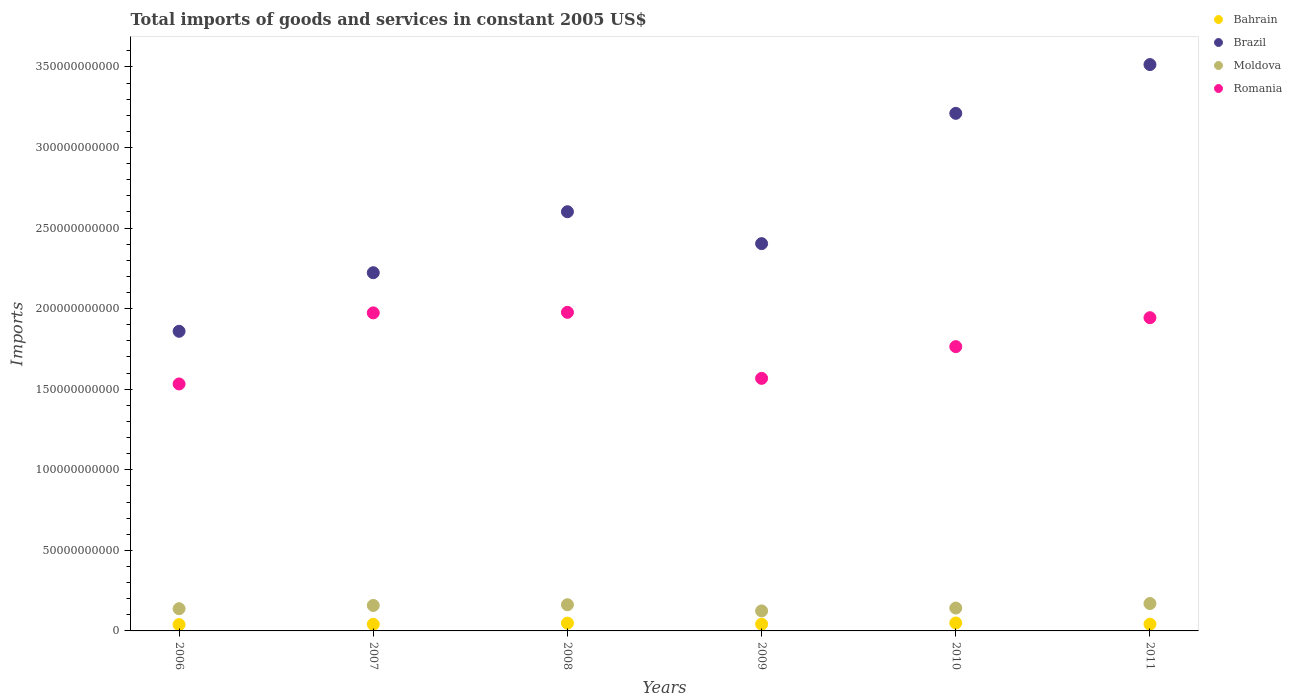Is the number of dotlines equal to the number of legend labels?
Your answer should be very brief. Yes. What is the total imports of goods and services in Bahrain in 2009?
Offer a very short reply. 4.20e+09. Across all years, what is the maximum total imports of goods and services in Bahrain?
Offer a very short reply. 4.92e+09. Across all years, what is the minimum total imports of goods and services in Bahrain?
Provide a short and direct response. 3.93e+09. What is the total total imports of goods and services in Romania in the graph?
Ensure brevity in your answer.  1.08e+12. What is the difference between the total imports of goods and services in Moldova in 2009 and that in 2010?
Provide a succinct answer. -1.77e+09. What is the difference between the total imports of goods and services in Bahrain in 2006 and the total imports of goods and services in Romania in 2010?
Give a very brief answer. -1.72e+11. What is the average total imports of goods and services in Brazil per year?
Your answer should be very brief. 2.64e+11. In the year 2009, what is the difference between the total imports of goods and services in Romania and total imports of goods and services in Moldova?
Ensure brevity in your answer.  1.44e+11. What is the ratio of the total imports of goods and services in Moldova in 2007 to that in 2011?
Your answer should be very brief. 0.93. Is the difference between the total imports of goods and services in Romania in 2006 and 2008 greater than the difference between the total imports of goods and services in Moldova in 2006 and 2008?
Provide a short and direct response. No. What is the difference between the highest and the second highest total imports of goods and services in Bahrain?
Your answer should be very brief. 9.00e+07. What is the difference between the highest and the lowest total imports of goods and services in Bahrain?
Ensure brevity in your answer.  9.95e+08. Is the sum of the total imports of goods and services in Moldova in 2008 and 2010 greater than the maximum total imports of goods and services in Brazil across all years?
Your response must be concise. No. Does the total imports of goods and services in Brazil monotonically increase over the years?
Your answer should be compact. No. Is the total imports of goods and services in Bahrain strictly less than the total imports of goods and services in Moldova over the years?
Give a very brief answer. Yes. How many dotlines are there?
Your answer should be compact. 4. How many years are there in the graph?
Provide a succinct answer. 6. Does the graph contain any zero values?
Your response must be concise. No. Does the graph contain grids?
Keep it short and to the point. No. Where does the legend appear in the graph?
Offer a very short reply. Top right. How many legend labels are there?
Your response must be concise. 4. What is the title of the graph?
Offer a terse response. Total imports of goods and services in constant 2005 US$. What is the label or title of the Y-axis?
Your answer should be compact. Imports. What is the Imports of Bahrain in 2006?
Make the answer very short. 3.93e+09. What is the Imports in Brazil in 2006?
Your answer should be compact. 1.86e+11. What is the Imports of Moldova in 2006?
Offer a very short reply. 1.38e+1. What is the Imports of Romania in 2006?
Offer a terse response. 1.53e+11. What is the Imports in Bahrain in 2007?
Keep it short and to the point. 4.10e+09. What is the Imports of Brazil in 2007?
Your answer should be compact. 2.22e+11. What is the Imports of Moldova in 2007?
Give a very brief answer. 1.58e+1. What is the Imports in Romania in 2007?
Offer a very short reply. 1.97e+11. What is the Imports of Bahrain in 2008?
Provide a short and direct response. 4.83e+09. What is the Imports in Brazil in 2008?
Your answer should be very brief. 2.60e+11. What is the Imports in Moldova in 2008?
Ensure brevity in your answer.  1.63e+1. What is the Imports of Romania in 2008?
Offer a terse response. 1.98e+11. What is the Imports of Bahrain in 2009?
Provide a short and direct response. 4.20e+09. What is the Imports of Brazil in 2009?
Offer a terse response. 2.40e+11. What is the Imports of Moldova in 2009?
Your response must be concise. 1.24e+1. What is the Imports in Romania in 2009?
Ensure brevity in your answer.  1.57e+11. What is the Imports of Bahrain in 2010?
Provide a succinct answer. 4.92e+09. What is the Imports in Brazil in 2010?
Provide a short and direct response. 3.21e+11. What is the Imports of Moldova in 2010?
Make the answer very short. 1.42e+1. What is the Imports in Romania in 2010?
Give a very brief answer. 1.76e+11. What is the Imports in Bahrain in 2011?
Your answer should be very brief. 4.20e+09. What is the Imports of Brazil in 2011?
Ensure brevity in your answer.  3.51e+11. What is the Imports in Moldova in 2011?
Offer a terse response. 1.70e+1. What is the Imports of Romania in 2011?
Offer a terse response. 1.94e+11. Across all years, what is the maximum Imports in Bahrain?
Offer a very short reply. 4.92e+09. Across all years, what is the maximum Imports in Brazil?
Keep it short and to the point. 3.51e+11. Across all years, what is the maximum Imports of Moldova?
Offer a very short reply. 1.70e+1. Across all years, what is the maximum Imports in Romania?
Provide a succinct answer. 1.98e+11. Across all years, what is the minimum Imports of Bahrain?
Make the answer very short. 3.93e+09. Across all years, what is the minimum Imports in Brazil?
Offer a terse response. 1.86e+11. Across all years, what is the minimum Imports in Moldova?
Offer a very short reply. 1.24e+1. Across all years, what is the minimum Imports of Romania?
Offer a terse response. 1.53e+11. What is the total Imports in Bahrain in the graph?
Offer a terse response. 2.62e+1. What is the total Imports in Brazil in the graph?
Provide a short and direct response. 1.58e+12. What is the total Imports in Moldova in the graph?
Make the answer very short. 8.94e+1. What is the total Imports of Romania in the graph?
Your answer should be compact. 1.08e+12. What is the difference between the Imports in Bahrain in 2006 and that in 2007?
Provide a succinct answer. -1.75e+08. What is the difference between the Imports of Brazil in 2006 and that in 2007?
Your answer should be compact. -3.64e+1. What is the difference between the Imports of Moldova in 2006 and that in 2007?
Ensure brevity in your answer.  -2.01e+09. What is the difference between the Imports of Romania in 2006 and that in 2007?
Ensure brevity in your answer.  -4.41e+1. What is the difference between the Imports in Bahrain in 2006 and that in 2008?
Offer a terse response. -9.05e+08. What is the difference between the Imports of Brazil in 2006 and that in 2008?
Offer a terse response. -7.42e+1. What is the difference between the Imports in Moldova in 2006 and that in 2008?
Keep it short and to the point. -2.46e+09. What is the difference between the Imports in Romania in 2006 and that in 2008?
Keep it short and to the point. -4.44e+1. What is the difference between the Imports in Bahrain in 2006 and that in 2009?
Provide a short and direct response. -2.68e+08. What is the difference between the Imports of Brazil in 2006 and that in 2009?
Make the answer very short. -5.44e+1. What is the difference between the Imports of Moldova in 2006 and that in 2009?
Ensure brevity in your answer.  1.37e+09. What is the difference between the Imports in Romania in 2006 and that in 2009?
Your response must be concise. -3.47e+09. What is the difference between the Imports in Bahrain in 2006 and that in 2010?
Keep it short and to the point. -9.95e+08. What is the difference between the Imports of Brazil in 2006 and that in 2010?
Provide a short and direct response. -1.35e+11. What is the difference between the Imports of Moldova in 2006 and that in 2010?
Offer a very short reply. -4.05e+08. What is the difference between the Imports of Romania in 2006 and that in 2010?
Your answer should be compact. -2.32e+1. What is the difference between the Imports of Bahrain in 2006 and that in 2011?
Provide a succinct answer. -2.68e+08. What is the difference between the Imports in Brazil in 2006 and that in 2011?
Offer a terse response. -1.66e+11. What is the difference between the Imports in Moldova in 2006 and that in 2011?
Your answer should be very brief. -3.20e+09. What is the difference between the Imports in Romania in 2006 and that in 2011?
Your answer should be very brief. -4.11e+1. What is the difference between the Imports in Bahrain in 2007 and that in 2008?
Give a very brief answer. -7.30e+08. What is the difference between the Imports of Brazil in 2007 and that in 2008?
Your answer should be very brief. -3.78e+1. What is the difference between the Imports in Moldova in 2007 and that in 2008?
Your answer should be very brief. -4.51e+08. What is the difference between the Imports in Romania in 2007 and that in 2008?
Make the answer very short. -3.45e+08. What is the difference between the Imports in Bahrain in 2007 and that in 2009?
Give a very brief answer. -9.39e+07. What is the difference between the Imports in Brazil in 2007 and that in 2009?
Ensure brevity in your answer.  -1.80e+1. What is the difference between the Imports of Moldova in 2007 and that in 2009?
Keep it short and to the point. 3.38e+09. What is the difference between the Imports in Romania in 2007 and that in 2009?
Give a very brief answer. 4.06e+1. What is the difference between the Imports of Bahrain in 2007 and that in 2010?
Offer a very short reply. -8.20e+08. What is the difference between the Imports in Brazil in 2007 and that in 2010?
Your answer should be compact. -9.89e+1. What is the difference between the Imports in Moldova in 2007 and that in 2010?
Provide a succinct answer. 1.61e+09. What is the difference between the Imports of Romania in 2007 and that in 2010?
Make the answer very short. 2.09e+1. What is the difference between the Imports in Bahrain in 2007 and that in 2011?
Your response must be concise. -9.29e+07. What is the difference between the Imports of Brazil in 2007 and that in 2011?
Make the answer very short. -1.29e+11. What is the difference between the Imports in Moldova in 2007 and that in 2011?
Provide a short and direct response. -1.19e+09. What is the difference between the Imports in Romania in 2007 and that in 2011?
Keep it short and to the point. 2.99e+09. What is the difference between the Imports of Bahrain in 2008 and that in 2009?
Your response must be concise. 6.36e+08. What is the difference between the Imports in Brazil in 2008 and that in 2009?
Offer a terse response. 1.98e+1. What is the difference between the Imports of Moldova in 2008 and that in 2009?
Your response must be concise. 3.83e+09. What is the difference between the Imports in Romania in 2008 and that in 2009?
Provide a short and direct response. 4.10e+1. What is the difference between the Imports of Bahrain in 2008 and that in 2010?
Keep it short and to the point. -9.00e+07. What is the difference between the Imports of Brazil in 2008 and that in 2010?
Provide a succinct answer. -6.10e+1. What is the difference between the Imports of Moldova in 2008 and that in 2010?
Keep it short and to the point. 2.06e+09. What is the difference between the Imports of Romania in 2008 and that in 2010?
Give a very brief answer. 2.13e+1. What is the difference between the Imports of Bahrain in 2008 and that in 2011?
Your response must be concise. 6.38e+08. What is the difference between the Imports of Brazil in 2008 and that in 2011?
Your answer should be compact. -9.13e+1. What is the difference between the Imports of Moldova in 2008 and that in 2011?
Make the answer very short. -7.35e+08. What is the difference between the Imports of Romania in 2008 and that in 2011?
Offer a terse response. 3.33e+09. What is the difference between the Imports in Bahrain in 2009 and that in 2010?
Ensure brevity in your answer.  -7.26e+08. What is the difference between the Imports in Brazil in 2009 and that in 2010?
Give a very brief answer. -8.08e+1. What is the difference between the Imports of Moldova in 2009 and that in 2010?
Provide a short and direct response. -1.77e+09. What is the difference between the Imports in Romania in 2009 and that in 2010?
Ensure brevity in your answer.  -1.97e+1. What is the difference between the Imports of Bahrain in 2009 and that in 2011?
Your response must be concise. 1.00e+06. What is the difference between the Imports in Brazil in 2009 and that in 2011?
Offer a terse response. -1.11e+11. What is the difference between the Imports of Moldova in 2009 and that in 2011?
Give a very brief answer. -4.56e+09. What is the difference between the Imports of Romania in 2009 and that in 2011?
Your answer should be very brief. -3.76e+1. What is the difference between the Imports of Bahrain in 2010 and that in 2011?
Give a very brief answer. 7.28e+08. What is the difference between the Imports of Brazil in 2010 and that in 2011?
Give a very brief answer. -3.03e+1. What is the difference between the Imports in Moldova in 2010 and that in 2011?
Provide a short and direct response. -2.79e+09. What is the difference between the Imports of Romania in 2010 and that in 2011?
Provide a succinct answer. -1.80e+1. What is the difference between the Imports in Bahrain in 2006 and the Imports in Brazil in 2007?
Ensure brevity in your answer.  -2.18e+11. What is the difference between the Imports in Bahrain in 2006 and the Imports in Moldova in 2007?
Your response must be concise. -1.19e+1. What is the difference between the Imports in Bahrain in 2006 and the Imports in Romania in 2007?
Make the answer very short. -1.93e+11. What is the difference between the Imports in Brazil in 2006 and the Imports in Moldova in 2007?
Your response must be concise. 1.70e+11. What is the difference between the Imports in Brazil in 2006 and the Imports in Romania in 2007?
Offer a very short reply. -1.14e+1. What is the difference between the Imports in Moldova in 2006 and the Imports in Romania in 2007?
Offer a terse response. -1.84e+11. What is the difference between the Imports of Bahrain in 2006 and the Imports of Brazil in 2008?
Ensure brevity in your answer.  -2.56e+11. What is the difference between the Imports of Bahrain in 2006 and the Imports of Moldova in 2008?
Offer a very short reply. -1.23e+1. What is the difference between the Imports of Bahrain in 2006 and the Imports of Romania in 2008?
Provide a short and direct response. -1.94e+11. What is the difference between the Imports of Brazil in 2006 and the Imports of Moldova in 2008?
Offer a very short reply. 1.70e+11. What is the difference between the Imports in Brazil in 2006 and the Imports in Romania in 2008?
Give a very brief answer. -1.18e+1. What is the difference between the Imports of Moldova in 2006 and the Imports of Romania in 2008?
Offer a very short reply. -1.84e+11. What is the difference between the Imports of Bahrain in 2006 and the Imports of Brazil in 2009?
Provide a short and direct response. -2.36e+11. What is the difference between the Imports of Bahrain in 2006 and the Imports of Moldova in 2009?
Provide a short and direct response. -8.49e+09. What is the difference between the Imports in Bahrain in 2006 and the Imports in Romania in 2009?
Provide a short and direct response. -1.53e+11. What is the difference between the Imports in Brazil in 2006 and the Imports in Moldova in 2009?
Make the answer very short. 1.74e+11. What is the difference between the Imports in Brazil in 2006 and the Imports in Romania in 2009?
Offer a terse response. 2.92e+1. What is the difference between the Imports in Moldova in 2006 and the Imports in Romania in 2009?
Offer a very short reply. -1.43e+11. What is the difference between the Imports in Bahrain in 2006 and the Imports in Brazil in 2010?
Provide a succinct answer. -3.17e+11. What is the difference between the Imports in Bahrain in 2006 and the Imports in Moldova in 2010?
Ensure brevity in your answer.  -1.03e+1. What is the difference between the Imports of Bahrain in 2006 and the Imports of Romania in 2010?
Make the answer very short. -1.72e+11. What is the difference between the Imports in Brazil in 2006 and the Imports in Moldova in 2010?
Your answer should be compact. 1.72e+11. What is the difference between the Imports of Brazil in 2006 and the Imports of Romania in 2010?
Ensure brevity in your answer.  9.52e+09. What is the difference between the Imports of Moldova in 2006 and the Imports of Romania in 2010?
Your answer should be very brief. -1.63e+11. What is the difference between the Imports in Bahrain in 2006 and the Imports in Brazil in 2011?
Ensure brevity in your answer.  -3.48e+11. What is the difference between the Imports in Bahrain in 2006 and the Imports in Moldova in 2011?
Offer a very short reply. -1.31e+1. What is the difference between the Imports in Bahrain in 2006 and the Imports in Romania in 2011?
Provide a succinct answer. -1.90e+11. What is the difference between the Imports of Brazil in 2006 and the Imports of Moldova in 2011?
Offer a very short reply. 1.69e+11. What is the difference between the Imports in Brazil in 2006 and the Imports in Romania in 2011?
Offer a terse response. -8.44e+09. What is the difference between the Imports in Moldova in 2006 and the Imports in Romania in 2011?
Keep it short and to the point. -1.81e+11. What is the difference between the Imports of Bahrain in 2007 and the Imports of Brazil in 2008?
Make the answer very short. -2.56e+11. What is the difference between the Imports of Bahrain in 2007 and the Imports of Moldova in 2008?
Your answer should be compact. -1.21e+1. What is the difference between the Imports in Bahrain in 2007 and the Imports in Romania in 2008?
Ensure brevity in your answer.  -1.94e+11. What is the difference between the Imports of Brazil in 2007 and the Imports of Moldova in 2008?
Your response must be concise. 2.06e+11. What is the difference between the Imports in Brazil in 2007 and the Imports in Romania in 2008?
Ensure brevity in your answer.  2.46e+1. What is the difference between the Imports in Moldova in 2007 and the Imports in Romania in 2008?
Provide a succinct answer. -1.82e+11. What is the difference between the Imports in Bahrain in 2007 and the Imports in Brazil in 2009?
Keep it short and to the point. -2.36e+11. What is the difference between the Imports in Bahrain in 2007 and the Imports in Moldova in 2009?
Keep it short and to the point. -8.32e+09. What is the difference between the Imports of Bahrain in 2007 and the Imports of Romania in 2009?
Offer a terse response. -1.53e+11. What is the difference between the Imports of Brazil in 2007 and the Imports of Moldova in 2009?
Give a very brief answer. 2.10e+11. What is the difference between the Imports of Brazil in 2007 and the Imports of Romania in 2009?
Your response must be concise. 6.56e+1. What is the difference between the Imports of Moldova in 2007 and the Imports of Romania in 2009?
Your response must be concise. -1.41e+11. What is the difference between the Imports in Bahrain in 2007 and the Imports in Brazil in 2010?
Offer a very short reply. -3.17e+11. What is the difference between the Imports of Bahrain in 2007 and the Imports of Moldova in 2010?
Provide a short and direct response. -1.01e+1. What is the difference between the Imports in Bahrain in 2007 and the Imports in Romania in 2010?
Your answer should be compact. -1.72e+11. What is the difference between the Imports of Brazil in 2007 and the Imports of Moldova in 2010?
Keep it short and to the point. 2.08e+11. What is the difference between the Imports of Brazil in 2007 and the Imports of Romania in 2010?
Your answer should be compact. 4.59e+1. What is the difference between the Imports in Moldova in 2007 and the Imports in Romania in 2010?
Your answer should be compact. -1.61e+11. What is the difference between the Imports of Bahrain in 2007 and the Imports of Brazil in 2011?
Keep it short and to the point. -3.47e+11. What is the difference between the Imports in Bahrain in 2007 and the Imports in Moldova in 2011?
Give a very brief answer. -1.29e+1. What is the difference between the Imports in Bahrain in 2007 and the Imports in Romania in 2011?
Your answer should be very brief. -1.90e+11. What is the difference between the Imports of Brazil in 2007 and the Imports of Moldova in 2011?
Provide a succinct answer. 2.05e+11. What is the difference between the Imports of Brazil in 2007 and the Imports of Romania in 2011?
Ensure brevity in your answer.  2.79e+1. What is the difference between the Imports of Moldova in 2007 and the Imports of Romania in 2011?
Your answer should be compact. -1.79e+11. What is the difference between the Imports of Bahrain in 2008 and the Imports of Brazil in 2009?
Provide a short and direct response. -2.36e+11. What is the difference between the Imports in Bahrain in 2008 and the Imports in Moldova in 2009?
Ensure brevity in your answer.  -7.59e+09. What is the difference between the Imports of Bahrain in 2008 and the Imports of Romania in 2009?
Keep it short and to the point. -1.52e+11. What is the difference between the Imports in Brazil in 2008 and the Imports in Moldova in 2009?
Keep it short and to the point. 2.48e+11. What is the difference between the Imports of Brazil in 2008 and the Imports of Romania in 2009?
Ensure brevity in your answer.  1.03e+11. What is the difference between the Imports in Moldova in 2008 and the Imports in Romania in 2009?
Offer a terse response. -1.40e+11. What is the difference between the Imports in Bahrain in 2008 and the Imports in Brazil in 2010?
Give a very brief answer. -3.16e+11. What is the difference between the Imports in Bahrain in 2008 and the Imports in Moldova in 2010?
Your response must be concise. -9.36e+09. What is the difference between the Imports of Bahrain in 2008 and the Imports of Romania in 2010?
Your response must be concise. -1.72e+11. What is the difference between the Imports of Brazil in 2008 and the Imports of Moldova in 2010?
Offer a terse response. 2.46e+11. What is the difference between the Imports in Brazil in 2008 and the Imports in Romania in 2010?
Offer a very short reply. 8.37e+1. What is the difference between the Imports of Moldova in 2008 and the Imports of Romania in 2010?
Make the answer very short. -1.60e+11. What is the difference between the Imports of Bahrain in 2008 and the Imports of Brazil in 2011?
Your response must be concise. -3.47e+11. What is the difference between the Imports of Bahrain in 2008 and the Imports of Moldova in 2011?
Provide a short and direct response. -1.22e+1. What is the difference between the Imports of Bahrain in 2008 and the Imports of Romania in 2011?
Your answer should be compact. -1.90e+11. What is the difference between the Imports in Brazil in 2008 and the Imports in Moldova in 2011?
Make the answer very short. 2.43e+11. What is the difference between the Imports in Brazil in 2008 and the Imports in Romania in 2011?
Keep it short and to the point. 6.58e+1. What is the difference between the Imports in Moldova in 2008 and the Imports in Romania in 2011?
Offer a very short reply. -1.78e+11. What is the difference between the Imports of Bahrain in 2009 and the Imports of Brazil in 2010?
Ensure brevity in your answer.  -3.17e+11. What is the difference between the Imports of Bahrain in 2009 and the Imports of Moldova in 2010?
Offer a terse response. -1.00e+1. What is the difference between the Imports in Bahrain in 2009 and the Imports in Romania in 2010?
Offer a very short reply. -1.72e+11. What is the difference between the Imports of Brazil in 2009 and the Imports of Moldova in 2010?
Provide a succinct answer. 2.26e+11. What is the difference between the Imports in Brazil in 2009 and the Imports in Romania in 2010?
Keep it short and to the point. 6.39e+1. What is the difference between the Imports in Moldova in 2009 and the Imports in Romania in 2010?
Your answer should be very brief. -1.64e+11. What is the difference between the Imports of Bahrain in 2009 and the Imports of Brazil in 2011?
Provide a short and direct response. -3.47e+11. What is the difference between the Imports of Bahrain in 2009 and the Imports of Moldova in 2011?
Offer a terse response. -1.28e+1. What is the difference between the Imports of Bahrain in 2009 and the Imports of Romania in 2011?
Provide a short and direct response. -1.90e+11. What is the difference between the Imports in Brazil in 2009 and the Imports in Moldova in 2011?
Provide a succinct answer. 2.23e+11. What is the difference between the Imports in Brazil in 2009 and the Imports in Romania in 2011?
Your answer should be very brief. 4.60e+1. What is the difference between the Imports in Moldova in 2009 and the Imports in Romania in 2011?
Your answer should be very brief. -1.82e+11. What is the difference between the Imports of Bahrain in 2010 and the Imports of Brazil in 2011?
Ensure brevity in your answer.  -3.47e+11. What is the difference between the Imports of Bahrain in 2010 and the Imports of Moldova in 2011?
Offer a very short reply. -1.21e+1. What is the difference between the Imports of Bahrain in 2010 and the Imports of Romania in 2011?
Provide a short and direct response. -1.89e+11. What is the difference between the Imports in Brazil in 2010 and the Imports in Moldova in 2011?
Your answer should be very brief. 3.04e+11. What is the difference between the Imports in Brazil in 2010 and the Imports in Romania in 2011?
Provide a succinct answer. 1.27e+11. What is the difference between the Imports in Moldova in 2010 and the Imports in Romania in 2011?
Give a very brief answer. -1.80e+11. What is the average Imports of Bahrain per year?
Your answer should be compact. 4.36e+09. What is the average Imports in Brazil per year?
Offer a terse response. 2.64e+11. What is the average Imports in Moldova per year?
Keep it short and to the point. 1.49e+1. What is the average Imports of Romania per year?
Your answer should be very brief. 1.79e+11. In the year 2006, what is the difference between the Imports of Bahrain and Imports of Brazil?
Keep it short and to the point. -1.82e+11. In the year 2006, what is the difference between the Imports in Bahrain and Imports in Moldova?
Your answer should be compact. -9.86e+09. In the year 2006, what is the difference between the Imports of Bahrain and Imports of Romania?
Offer a very short reply. -1.49e+11. In the year 2006, what is the difference between the Imports of Brazil and Imports of Moldova?
Provide a short and direct response. 1.72e+11. In the year 2006, what is the difference between the Imports in Brazil and Imports in Romania?
Give a very brief answer. 3.27e+1. In the year 2006, what is the difference between the Imports of Moldova and Imports of Romania?
Provide a succinct answer. -1.39e+11. In the year 2007, what is the difference between the Imports of Bahrain and Imports of Brazil?
Give a very brief answer. -2.18e+11. In the year 2007, what is the difference between the Imports in Bahrain and Imports in Moldova?
Your answer should be very brief. -1.17e+1. In the year 2007, what is the difference between the Imports of Bahrain and Imports of Romania?
Make the answer very short. -1.93e+11. In the year 2007, what is the difference between the Imports of Brazil and Imports of Moldova?
Provide a short and direct response. 2.06e+11. In the year 2007, what is the difference between the Imports in Brazil and Imports in Romania?
Keep it short and to the point. 2.49e+1. In the year 2007, what is the difference between the Imports in Moldova and Imports in Romania?
Your answer should be very brief. -1.82e+11. In the year 2008, what is the difference between the Imports of Bahrain and Imports of Brazil?
Your answer should be very brief. -2.55e+11. In the year 2008, what is the difference between the Imports in Bahrain and Imports in Moldova?
Provide a succinct answer. -1.14e+1. In the year 2008, what is the difference between the Imports of Bahrain and Imports of Romania?
Offer a terse response. -1.93e+11. In the year 2008, what is the difference between the Imports in Brazil and Imports in Moldova?
Your response must be concise. 2.44e+11. In the year 2008, what is the difference between the Imports of Brazil and Imports of Romania?
Offer a terse response. 6.24e+1. In the year 2008, what is the difference between the Imports of Moldova and Imports of Romania?
Your answer should be very brief. -1.81e+11. In the year 2009, what is the difference between the Imports of Bahrain and Imports of Brazil?
Provide a succinct answer. -2.36e+11. In the year 2009, what is the difference between the Imports of Bahrain and Imports of Moldova?
Give a very brief answer. -8.22e+09. In the year 2009, what is the difference between the Imports of Bahrain and Imports of Romania?
Your answer should be compact. -1.53e+11. In the year 2009, what is the difference between the Imports of Brazil and Imports of Moldova?
Offer a terse response. 2.28e+11. In the year 2009, what is the difference between the Imports in Brazil and Imports in Romania?
Your answer should be compact. 8.36e+1. In the year 2009, what is the difference between the Imports of Moldova and Imports of Romania?
Your response must be concise. -1.44e+11. In the year 2010, what is the difference between the Imports of Bahrain and Imports of Brazil?
Your answer should be compact. -3.16e+11. In the year 2010, what is the difference between the Imports of Bahrain and Imports of Moldova?
Ensure brevity in your answer.  -9.27e+09. In the year 2010, what is the difference between the Imports of Bahrain and Imports of Romania?
Keep it short and to the point. -1.71e+11. In the year 2010, what is the difference between the Imports of Brazil and Imports of Moldova?
Provide a succinct answer. 3.07e+11. In the year 2010, what is the difference between the Imports of Brazil and Imports of Romania?
Give a very brief answer. 1.45e+11. In the year 2010, what is the difference between the Imports of Moldova and Imports of Romania?
Ensure brevity in your answer.  -1.62e+11. In the year 2011, what is the difference between the Imports in Bahrain and Imports in Brazil?
Your response must be concise. -3.47e+11. In the year 2011, what is the difference between the Imports in Bahrain and Imports in Moldova?
Make the answer very short. -1.28e+1. In the year 2011, what is the difference between the Imports of Bahrain and Imports of Romania?
Keep it short and to the point. -1.90e+11. In the year 2011, what is the difference between the Imports in Brazil and Imports in Moldova?
Your answer should be compact. 3.34e+11. In the year 2011, what is the difference between the Imports in Brazil and Imports in Romania?
Offer a very short reply. 1.57e+11. In the year 2011, what is the difference between the Imports in Moldova and Imports in Romania?
Make the answer very short. -1.77e+11. What is the ratio of the Imports in Bahrain in 2006 to that in 2007?
Ensure brevity in your answer.  0.96. What is the ratio of the Imports of Brazil in 2006 to that in 2007?
Your response must be concise. 0.84. What is the ratio of the Imports of Moldova in 2006 to that in 2007?
Offer a terse response. 0.87. What is the ratio of the Imports in Romania in 2006 to that in 2007?
Offer a very short reply. 0.78. What is the ratio of the Imports in Bahrain in 2006 to that in 2008?
Provide a short and direct response. 0.81. What is the ratio of the Imports of Brazil in 2006 to that in 2008?
Ensure brevity in your answer.  0.71. What is the ratio of the Imports in Moldova in 2006 to that in 2008?
Your answer should be compact. 0.85. What is the ratio of the Imports of Romania in 2006 to that in 2008?
Your response must be concise. 0.78. What is the ratio of the Imports of Bahrain in 2006 to that in 2009?
Make the answer very short. 0.94. What is the ratio of the Imports of Brazil in 2006 to that in 2009?
Provide a succinct answer. 0.77. What is the ratio of the Imports of Moldova in 2006 to that in 2009?
Make the answer very short. 1.11. What is the ratio of the Imports of Romania in 2006 to that in 2009?
Your answer should be compact. 0.98. What is the ratio of the Imports in Bahrain in 2006 to that in 2010?
Your answer should be very brief. 0.8. What is the ratio of the Imports of Brazil in 2006 to that in 2010?
Provide a short and direct response. 0.58. What is the ratio of the Imports of Moldova in 2006 to that in 2010?
Your answer should be compact. 0.97. What is the ratio of the Imports in Romania in 2006 to that in 2010?
Keep it short and to the point. 0.87. What is the ratio of the Imports in Bahrain in 2006 to that in 2011?
Offer a very short reply. 0.94. What is the ratio of the Imports in Brazil in 2006 to that in 2011?
Your answer should be compact. 0.53. What is the ratio of the Imports in Moldova in 2006 to that in 2011?
Your answer should be compact. 0.81. What is the ratio of the Imports of Romania in 2006 to that in 2011?
Provide a short and direct response. 0.79. What is the ratio of the Imports in Bahrain in 2007 to that in 2008?
Your response must be concise. 0.85. What is the ratio of the Imports of Brazil in 2007 to that in 2008?
Your answer should be compact. 0.85. What is the ratio of the Imports in Moldova in 2007 to that in 2008?
Ensure brevity in your answer.  0.97. What is the ratio of the Imports in Romania in 2007 to that in 2008?
Give a very brief answer. 1. What is the ratio of the Imports in Bahrain in 2007 to that in 2009?
Offer a very short reply. 0.98. What is the ratio of the Imports of Brazil in 2007 to that in 2009?
Ensure brevity in your answer.  0.92. What is the ratio of the Imports in Moldova in 2007 to that in 2009?
Give a very brief answer. 1.27. What is the ratio of the Imports in Romania in 2007 to that in 2009?
Your answer should be very brief. 1.26. What is the ratio of the Imports in Bahrain in 2007 to that in 2010?
Provide a succinct answer. 0.83. What is the ratio of the Imports in Brazil in 2007 to that in 2010?
Your answer should be very brief. 0.69. What is the ratio of the Imports of Moldova in 2007 to that in 2010?
Your response must be concise. 1.11. What is the ratio of the Imports of Romania in 2007 to that in 2010?
Your answer should be compact. 1.12. What is the ratio of the Imports of Bahrain in 2007 to that in 2011?
Make the answer very short. 0.98. What is the ratio of the Imports in Brazil in 2007 to that in 2011?
Give a very brief answer. 0.63. What is the ratio of the Imports in Moldova in 2007 to that in 2011?
Provide a succinct answer. 0.93. What is the ratio of the Imports in Romania in 2007 to that in 2011?
Your response must be concise. 1.02. What is the ratio of the Imports in Bahrain in 2008 to that in 2009?
Keep it short and to the point. 1.15. What is the ratio of the Imports of Brazil in 2008 to that in 2009?
Make the answer very short. 1.08. What is the ratio of the Imports in Moldova in 2008 to that in 2009?
Make the answer very short. 1.31. What is the ratio of the Imports of Romania in 2008 to that in 2009?
Your answer should be very brief. 1.26. What is the ratio of the Imports of Bahrain in 2008 to that in 2010?
Provide a succinct answer. 0.98. What is the ratio of the Imports of Brazil in 2008 to that in 2010?
Provide a short and direct response. 0.81. What is the ratio of the Imports of Moldova in 2008 to that in 2010?
Make the answer very short. 1.15. What is the ratio of the Imports in Romania in 2008 to that in 2010?
Your answer should be compact. 1.12. What is the ratio of the Imports in Bahrain in 2008 to that in 2011?
Make the answer very short. 1.15. What is the ratio of the Imports of Brazil in 2008 to that in 2011?
Your answer should be compact. 0.74. What is the ratio of the Imports in Moldova in 2008 to that in 2011?
Your answer should be very brief. 0.96. What is the ratio of the Imports of Romania in 2008 to that in 2011?
Ensure brevity in your answer.  1.02. What is the ratio of the Imports of Bahrain in 2009 to that in 2010?
Give a very brief answer. 0.85. What is the ratio of the Imports in Brazil in 2009 to that in 2010?
Keep it short and to the point. 0.75. What is the ratio of the Imports of Moldova in 2009 to that in 2010?
Your response must be concise. 0.88. What is the ratio of the Imports in Romania in 2009 to that in 2010?
Your answer should be compact. 0.89. What is the ratio of the Imports of Bahrain in 2009 to that in 2011?
Offer a very short reply. 1. What is the ratio of the Imports of Brazil in 2009 to that in 2011?
Ensure brevity in your answer.  0.68. What is the ratio of the Imports of Moldova in 2009 to that in 2011?
Your answer should be compact. 0.73. What is the ratio of the Imports of Romania in 2009 to that in 2011?
Keep it short and to the point. 0.81. What is the ratio of the Imports of Bahrain in 2010 to that in 2011?
Ensure brevity in your answer.  1.17. What is the ratio of the Imports in Brazil in 2010 to that in 2011?
Your answer should be very brief. 0.91. What is the ratio of the Imports of Moldova in 2010 to that in 2011?
Give a very brief answer. 0.84. What is the ratio of the Imports in Romania in 2010 to that in 2011?
Your response must be concise. 0.91. What is the difference between the highest and the second highest Imports of Bahrain?
Keep it short and to the point. 9.00e+07. What is the difference between the highest and the second highest Imports in Brazil?
Provide a succinct answer. 3.03e+1. What is the difference between the highest and the second highest Imports in Moldova?
Provide a short and direct response. 7.35e+08. What is the difference between the highest and the second highest Imports in Romania?
Provide a succinct answer. 3.45e+08. What is the difference between the highest and the lowest Imports in Bahrain?
Make the answer very short. 9.95e+08. What is the difference between the highest and the lowest Imports of Brazil?
Keep it short and to the point. 1.66e+11. What is the difference between the highest and the lowest Imports in Moldova?
Your answer should be compact. 4.56e+09. What is the difference between the highest and the lowest Imports in Romania?
Keep it short and to the point. 4.44e+1. 